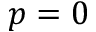Convert formula to latex. <formula><loc_0><loc_0><loc_500><loc_500>p = 0</formula> 